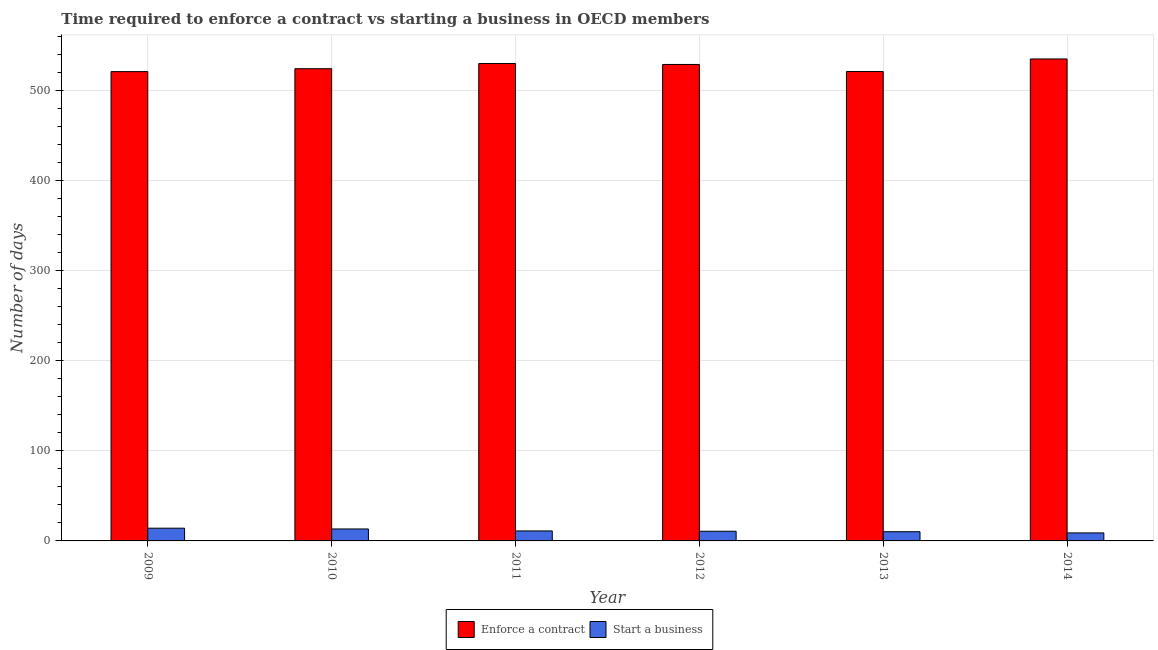How many different coloured bars are there?
Your answer should be very brief. 2. How many bars are there on the 6th tick from the left?
Your answer should be very brief. 2. What is the label of the 4th group of bars from the left?
Offer a terse response. 2012. In how many cases, is the number of bars for a given year not equal to the number of legend labels?
Ensure brevity in your answer.  0. What is the number of days to enforece a contract in 2010?
Keep it short and to the point. 524.74. Across all years, what is the maximum number of days to enforece a contract?
Offer a very short reply. 535.56. Across all years, what is the minimum number of days to enforece a contract?
Your answer should be compact. 521.52. In which year was the number of days to enforece a contract maximum?
Your response must be concise. 2014. What is the total number of days to start a business in the graph?
Offer a terse response. 68.42. What is the difference between the number of days to enforece a contract in 2009 and that in 2010?
Offer a very short reply. -3.23. What is the difference between the number of days to enforece a contract in 2012 and the number of days to start a business in 2014?
Offer a very short reply. -6.11. What is the average number of days to start a business per year?
Offer a very short reply. 11.4. What is the ratio of the number of days to start a business in 2009 to that in 2013?
Give a very brief answer. 1.38. What is the difference between the highest and the second highest number of days to start a business?
Keep it short and to the point. 0.85. What is the difference between the highest and the lowest number of days to enforece a contract?
Your response must be concise. 14.04. In how many years, is the number of days to start a business greater than the average number of days to start a business taken over all years?
Provide a succinct answer. 2. What does the 1st bar from the left in 2013 represents?
Your answer should be compact. Enforce a contract. What does the 1st bar from the right in 2010 represents?
Ensure brevity in your answer.  Start a business. How many bars are there?
Your answer should be very brief. 12. Does the graph contain grids?
Make the answer very short. Yes. Where does the legend appear in the graph?
Your answer should be compact. Bottom center. How many legend labels are there?
Ensure brevity in your answer.  2. What is the title of the graph?
Keep it short and to the point. Time required to enforce a contract vs starting a business in OECD members. What is the label or title of the Y-axis?
Give a very brief answer. Number of days. What is the Number of days of Enforce a contract in 2009?
Keep it short and to the point. 521.52. What is the Number of days of Start a business in 2009?
Offer a terse response. 14.15. What is the Number of days of Enforce a contract in 2010?
Your response must be concise. 524.74. What is the Number of days in Start a business in 2010?
Give a very brief answer. 13.29. What is the Number of days in Enforce a contract in 2011?
Your answer should be compact. 530.48. What is the Number of days of Start a business in 2011?
Your answer should be very brief. 11.1. What is the Number of days in Enforce a contract in 2012?
Provide a succinct answer. 529.45. What is the Number of days of Start a business in 2012?
Your answer should be very brief. 10.74. What is the Number of days in Enforce a contract in 2013?
Give a very brief answer. 521.59. What is the Number of days in Start a business in 2013?
Your response must be concise. 10.24. What is the Number of days of Enforce a contract in 2014?
Offer a very short reply. 535.56. What is the Number of days of Start a business in 2014?
Give a very brief answer. 8.9. Across all years, what is the maximum Number of days of Enforce a contract?
Your answer should be compact. 535.56. Across all years, what is the maximum Number of days in Start a business?
Ensure brevity in your answer.  14.15. Across all years, what is the minimum Number of days in Enforce a contract?
Your answer should be very brief. 521.52. What is the total Number of days of Enforce a contract in the graph?
Provide a succinct answer. 3163.34. What is the total Number of days in Start a business in the graph?
Ensure brevity in your answer.  68.42. What is the difference between the Number of days in Enforce a contract in 2009 and that in 2010?
Provide a short and direct response. -3.23. What is the difference between the Number of days of Start a business in 2009 and that in 2010?
Give a very brief answer. 0.85. What is the difference between the Number of days of Enforce a contract in 2009 and that in 2011?
Your answer should be very brief. -8.97. What is the difference between the Number of days in Start a business in 2009 and that in 2011?
Your answer should be compact. 3.05. What is the difference between the Number of days in Enforce a contract in 2009 and that in 2012?
Ensure brevity in your answer.  -7.94. What is the difference between the Number of days of Start a business in 2009 and that in 2012?
Give a very brief answer. 3.4. What is the difference between the Number of days in Enforce a contract in 2009 and that in 2013?
Keep it short and to the point. -0.07. What is the difference between the Number of days in Start a business in 2009 and that in 2013?
Ensure brevity in your answer.  3.9. What is the difference between the Number of days in Enforce a contract in 2009 and that in 2014?
Keep it short and to the point. -14.04. What is the difference between the Number of days of Start a business in 2009 and that in 2014?
Ensure brevity in your answer.  5.25. What is the difference between the Number of days in Enforce a contract in 2010 and that in 2011?
Ensure brevity in your answer.  -5.74. What is the difference between the Number of days in Start a business in 2010 and that in 2011?
Offer a terse response. 2.19. What is the difference between the Number of days in Enforce a contract in 2010 and that in 2012?
Your response must be concise. -4.71. What is the difference between the Number of days of Start a business in 2010 and that in 2012?
Your response must be concise. 2.55. What is the difference between the Number of days of Enforce a contract in 2010 and that in 2013?
Your answer should be very brief. 3.15. What is the difference between the Number of days in Start a business in 2010 and that in 2013?
Provide a short and direct response. 3.05. What is the difference between the Number of days in Enforce a contract in 2010 and that in 2014?
Your answer should be compact. -10.82. What is the difference between the Number of days of Start a business in 2010 and that in 2014?
Your response must be concise. 4.39. What is the difference between the Number of days in Enforce a contract in 2011 and that in 2012?
Ensure brevity in your answer.  1.03. What is the difference between the Number of days in Start a business in 2011 and that in 2012?
Offer a terse response. 0.35. What is the difference between the Number of days of Enforce a contract in 2011 and that in 2013?
Provide a succinct answer. 8.9. What is the difference between the Number of days in Start a business in 2011 and that in 2013?
Your answer should be very brief. 0.86. What is the difference between the Number of days of Enforce a contract in 2011 and that in 2014?
Offer a terse response. -5.08. What is the difference between the Number of days in Start a business in 2011 and that in 2014?
Keep it short and to the point. 2.2. What is the difference between the Number of days of Enforce a contract in 2012 and that in 2013?
Offer a terse response. 7.86. What is the difference between the Number of days of Start a business in 2012 and that in 2013?
Offer a very short reply. 0.5. What is the difference between the Number of days of Enforce a contract in 2012 and that in 2014?
Provide a short and direct response. -6.11. What is the difference between the Number of days of Start a business in 2012 and that in 2014?
Make the answer very short. 1.84. What is the difference between the Number of days in Enforce a contract in 2013 and that in 2014?
Offer a terse response. -13.97. What is the difference between the Number of days of Start a business in 2013 and that in 2014?
Keep it short and to the point. 1.34. What is the difference between the Number of days of Enforce a contract in 2009 and the Number of days of Start a business in 2010?
Provide a succinct answer. 508.23. What is the difference between the Number of days of Enforce a contract in 2009 and the Number of days of Start a business in 2011?
Make the answer very short. 510.42. What is the difference between the Number of days of Enforce a contract in 2009 and the Number of days of Start a business in 2012?
Ensure brevity in your answer.  510.77. What is the difference between the Number of days of Enforce a contract in 2009 and the Number of days of Start a business in 2013?
Make the answer very short. 511.27. What is the difference between the Number of days in Enforce a contract in 2009 and the Number of days in Start a business in 2014?
Give a very brief answer. 512.62. What is the difference between the Number of days of Enforce a contract in 2010 and the Number of days of Start a business in 2011?
Offer a terse response. 513.65. What is the difference between the Number of days of Enforce a contract in 2010 and the Number of days of Start a business in 2012?
Your answer should be compact. 514. What is the difference between the Number of days in Enforce a contract in 2010 and the Number of days in Start a business in 2013?
Make the answer very short. 514.5. What is the difference between the Number of days of Enforce a contract in 2010 and the Number of days of Start a business in 2014?
Make the answer very short. 515.84. What is the difference between the Number of days in Enforce a contract in 2011 and the Number of days in Start a business in 2012?
Your answer should be very brief. 519.74. What is the difference between the Number of days of Enforce a contract in 2011 and the Number of days of Start a business in 2013?
Your answer should be very brief. 520.24. What is the difference between the Number of days in Enforce a contract in 2011 and the Number of days in Start a business in 2014?
Offer a very short reply. 521.58. What is the difference between the Number of days of Enforce a contract in 2012 and the Number of days of Start a business in 2013?
Your response must be concise. 519.21. What is the difference between the Number of days of Enforce a contract in 2012 and the Number of days of Start a business in 2014?
Provide a short and direct response. 520.55. What is the difference between the Number of days in Enforce a contract in 2013 and the Number of days in Start a business in 2014?
Provide a short and direct response. 512.69. What is the average Number of days of Enforce a contract per year?
Provide a short and direct response. 527.22. What is the average Number of days in Start a business per year?
Give a very brief answer. 11.4. In the year 2009, what is the difference between the Number of days of Enforce a contract and Number of days of Start a business?
Your answer should be compact. 507.37. In the year 2010, what is the difference between the Number of days in Enforce a contract and Number of days in Start a business?
Ensure brevity in your answer.  511.45. In the year 2011, what is the difference between the Number of days in Enforce a contract and Number of days in Start a business?
Your answer should be very brief. 519.39. In the year 2012, what is the difference between the Number of days of Enforce a contract and Number of days of Start a business?
Provide a succinct answer. 518.71. In the year 2013, what is the difference between the Number of days in Enforce a contract and Number of days in Start a business?
Your response must be concise. 511.35. In the year 2014, what is the difference between the Number of days in Enforce a contract and Number of days in Start a business?
Ensure brevity in your answer.  526.66. What is the ratio of the Number of days of Enforce a contract in 2009 to that in 2010?
Keep it short and to the point. 0.99. What is the ratio of the Number of days in Start a business in 2009 to that in 2010?
Keep it short and to the point. 1.06. What is the ratio of the Number of days in Enforce a contract in 2009 to that in 2011?
Your answer should be very brief. 0.98. What is the ratio of the Number of days of Start a business in 2009 to that in 2011?
Your answer should be very brief. 1.27. What is the ratio of the Number of days in Enforce a contract in 2009 to that in 2012?
Your answer should be compact. 0.98. What is the ratio of the Number of days in Start a business in 2009 to that in 2012?
Make the answer very short. 1.32. What is the ratio of the Number of days of Enforce a contract in 2009 to that in 2013?
Give a very brief answer. 1. What is the ratio of the Number of days of Start a business in 2009 to that in 2013?
Your response must be concise. 1.38. What is the ratio of the Number of days of Enforce a contract in 2009 to that in 2014?
Offer a very short reply. 0.97. What is the ratio of the Number of days of Start a business in 2009 to that in 2014?
Your answer should be very brief. 1.59. What is the ratio of the Number of days of Start a business in 2010 to that in 2011?
Provide a short and direct response. 1.2. What is the ratio of the Number of days in Start a business in 2010 to that in 2012?
Provide a short and direct response. 1.24. What is the ratio of the Number of days in Enforce a contract in 2010 to that in 2013?
Keep it short and to the point. 1.01. What is the ratio of the Number of days of Start a business in 2010 to that in 2013?
Ensure brevity in your answer.  1.3. What is the ratio of the Number of days in Enforce a contract in 2010 to that in 2014?
Your answer should be very brief. 0.98. What is the ratio of the Number of days in Start a business in 2010 to that in 2014?
Offer a very short reply. 1.49. What is the ratio of the Number of days of Enforce a contract in 2011 to that in 2012?
Your answer should be compact. 1. What is the ratio of the Number of days of Start a business in 2011 to that in 2012?
Provide a succinct answer. 1.03. What is the ratio of the Number of days of Enforce a contract in 2011 to that in 2013?
Your answer should be compact. 1.02. What is the ratio of the Number of days in Start a business in 2011 to that in 2013?
Provide a short and direct response. 1.08. What is the ratio of the Number of days of Enforce a contract in 2011 to that in 2014?
Provide a succinct answer. 0.99. What is the ratio of the Number of days of Start a business in 2011 to that in 2014?
Offer a very short reply. 1.25. What is the ratio of the Number of days in Enforce a contract in 2012 to that in 2013?
Provide a succinct answer. 1.02. What is the ratio of the Number of days of Start a business in 2012 to that in 2013?
Keep it short and to the point. 1.05. What is the ratio of the Number of days of Start a business in 2012 to that in 2014?
Offer a very short reply. 1.21. What is the ratio of the Number of days in Enforce a contract in 2013 to that in 2014?
Offer a very short reply. 0.97. What is the ratio of the Number of days of Start a business in 2013 to that in 2014?
Ensure brevity in your answer.  1.15. What is the difference between the highest and the second highest Number of days in Enforce a contract?
Provide a short and direct response. 5.08. What is the difference between the highest and the second highest Number of days of Start a business?
Ensure brevity in your answer.  0.85. What is the difference between the highest and the lowest Number of days in Enforce a contract?
Offer a terse response. 14.04. What is the difference between the highest and the lowest Number of days of Start a business?
Your answer should be compact. 5.25. 